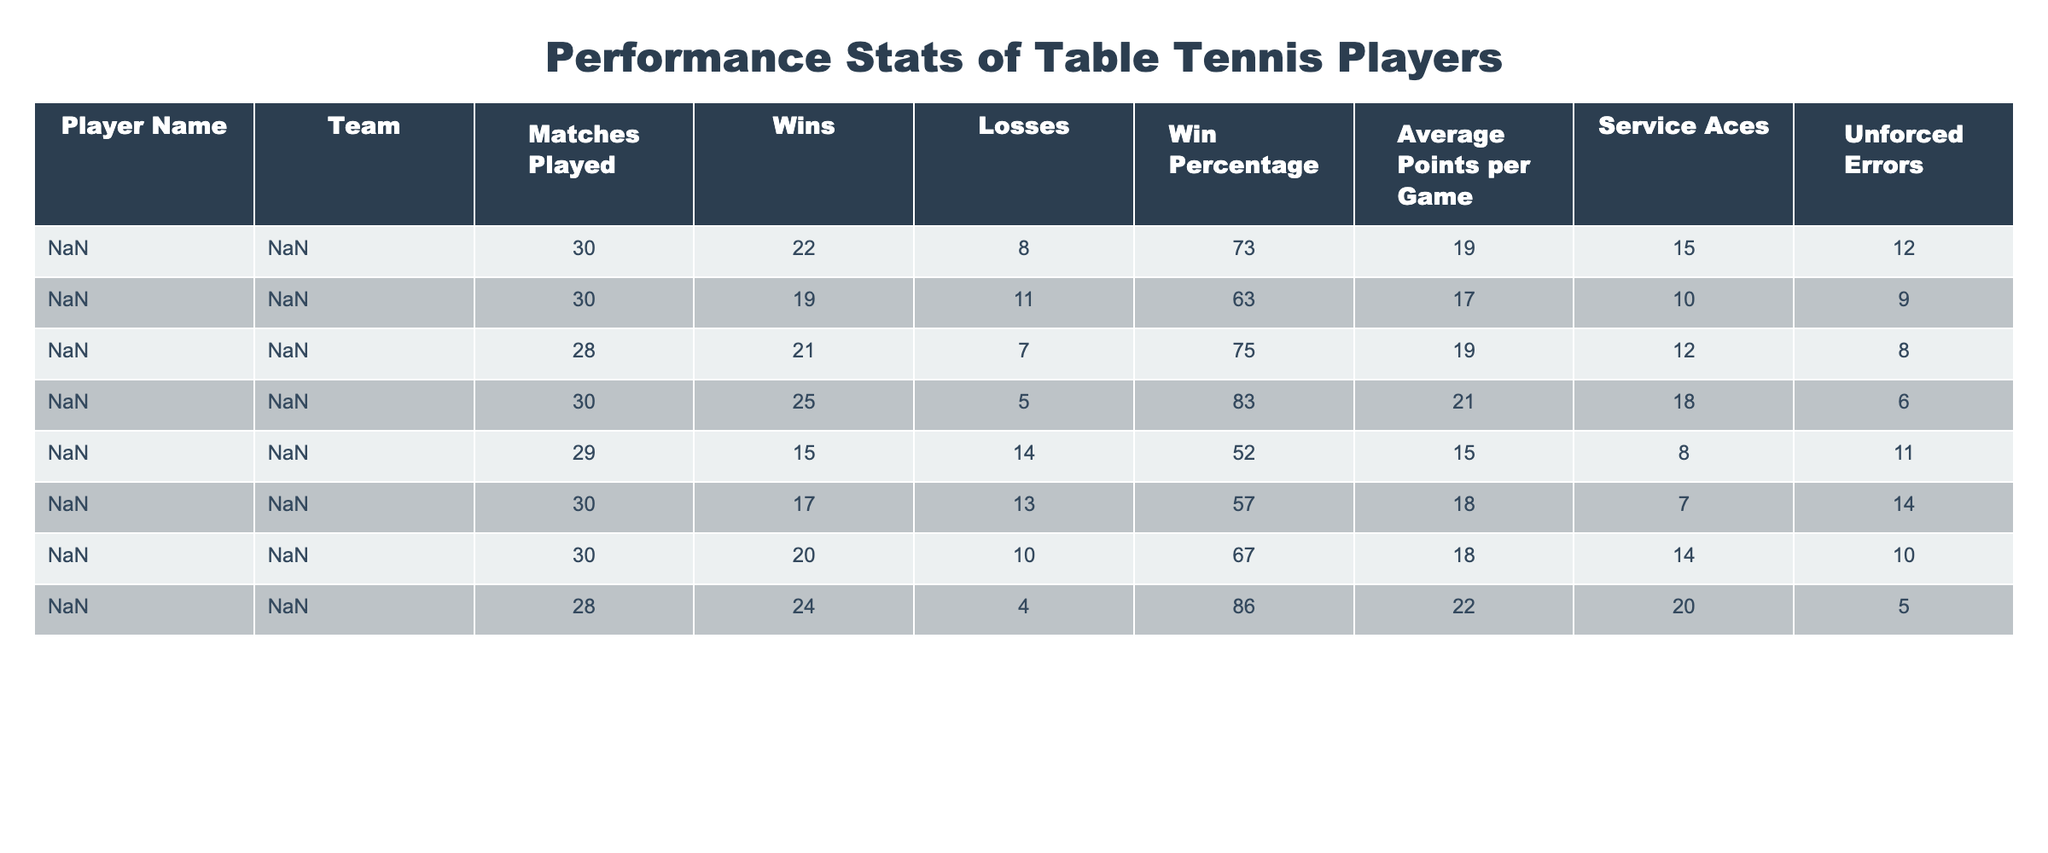What is the win percentage of Henry Thompson? In the table, I find the row corresponding to Henry Thompson. The win percentage column for Henry Thompson shows 85.7.
Answer: 85.7 Who had the highest number of service aces? By looking at the service aces column, I see David Wang with 18 service aces, which is the maximum compared to others in the team.
Answer: David Wang How many games did Alice Johnson win? Referring to the wins column, Alice Johnson's wins are listed as 22.
Answer: 22 What is the average points per game for players who won more than 20 matches? First, I identify players with more than 20 wins: David Wang (20.6) and Catherine Patel (19.2). Next, I take the average of their points: (20.6 + 19.2) / 2 = 19.9.
Answer: 19.9 Is it true that Ella Martinez has more unforced errors than Frank Liu? Checking the unforced errors column, Ella Martinez has 11 while Frank Liu has 14. Therefore, the statement is false.
Answer: No Which player had the lowest win percentage? To find this, I look at the win percentage column and see that Ella Martinez has the lowest figure at 51.7.
Answer: Ella Martinez How many total wins did the team have across all players? I add the wins across all players: 22 + 19 + 21 + 25 + 15 + 17 + 20 + 24 = 143 total wins.
Answer: 143 Which player has the most losses in the North Tigers team? Looking at the losses column, I find that Ella Martinez has the highest number of losses at 14.
Answer: Ella Martinez What is the difference in average points per game between the player with the most wins and the player with the least wins? Identifying the max wins (David Wang with 25 points) and min wins (Ella Martinez with 15 points), I find their average points per game as 20.6 and 15.1 respectively. The difference is 20.6 - 15.1 = 5.5.
Answer: 5.5 